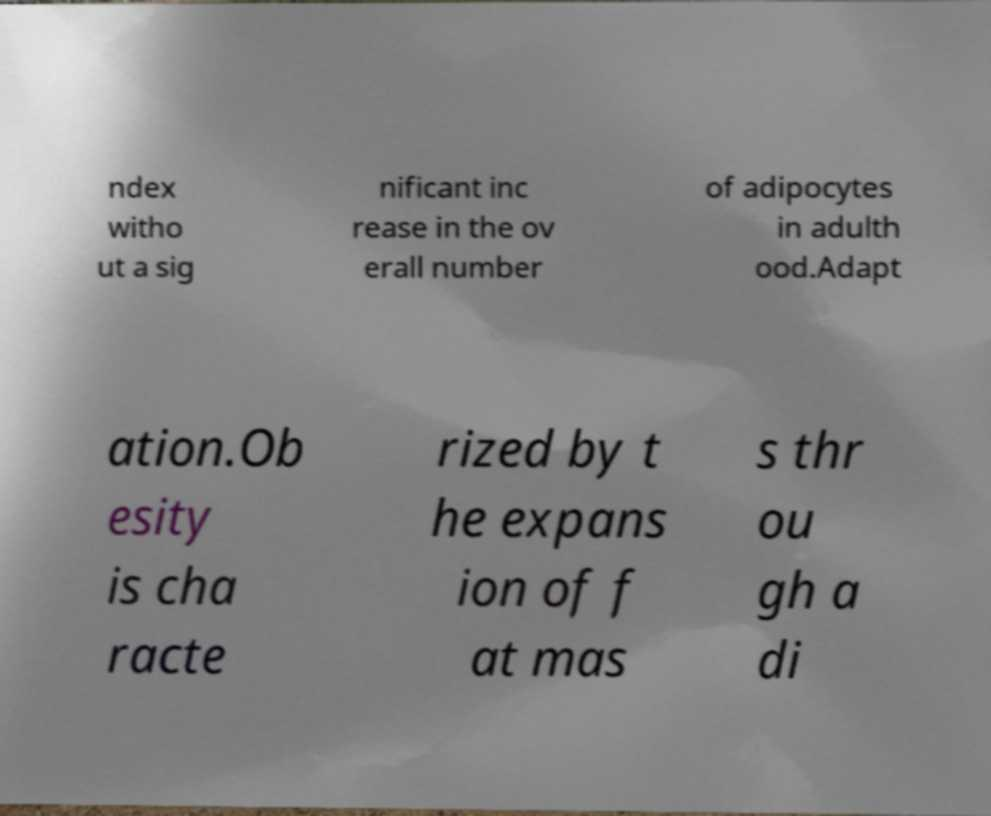Can you accurately transcribe the text from the provided image for me? ndex witho ut a sig nificant inc rease in the ov erall number of adipocytes in adulth ood.Adapt ation.Ob esity is cha racte rized by t he expans ion of f at mas s thr ou gh a di 